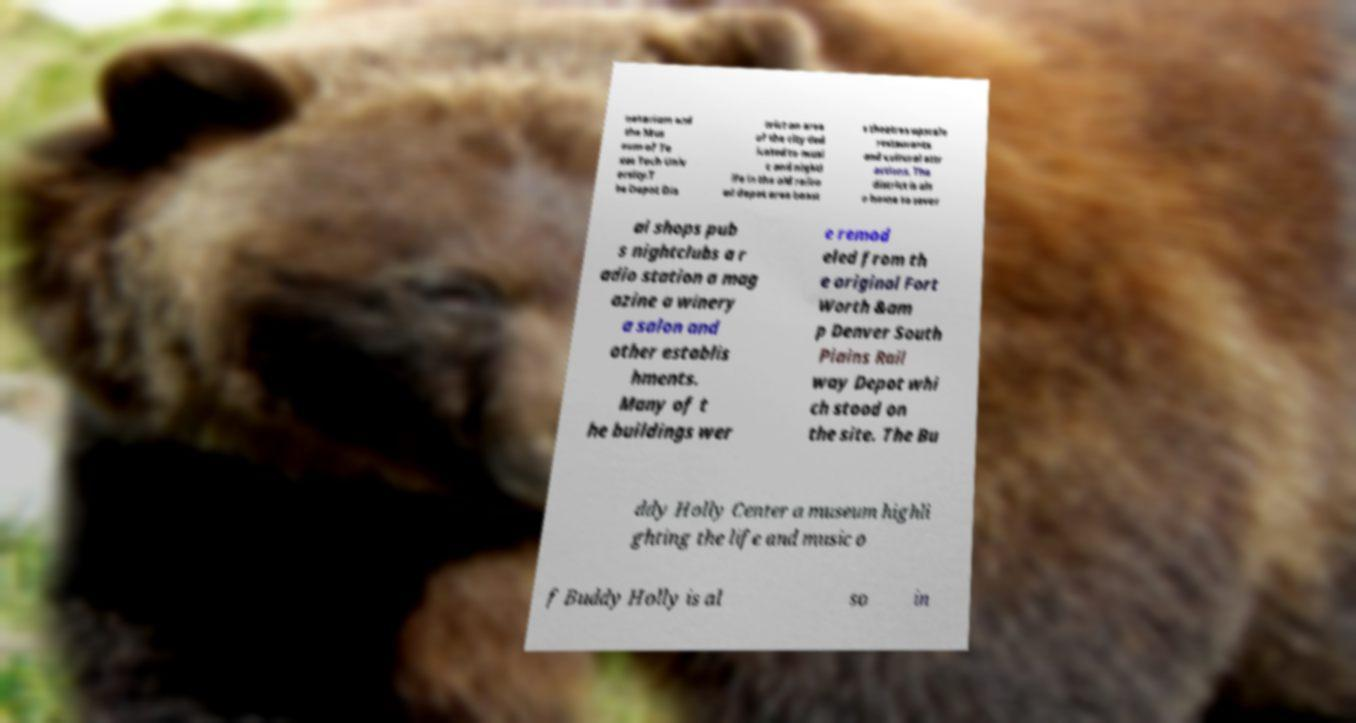Can you accurately transcribe the text from the provided image for me? netarium and the Mus eum of Te xas Tech Univ ersity.T he Depot Dis trict an area of the city ded icated to musi c and nightl ife in the old railro ad depot area boast s theatres upscale restaurants and cultural attr actions. The district is als o home to sever al shops pub s nightclubs a r adio station a mag azine a winery a salon and other establis hments. Many of t he buildings wer e remod eled from th e original Fort Worth &am p Denver South Plains Rail way Depot whi ch stood on the site. The Bu ddy Holly Center a museum highli ghting the life and music o f Buddy Holly is al so in 